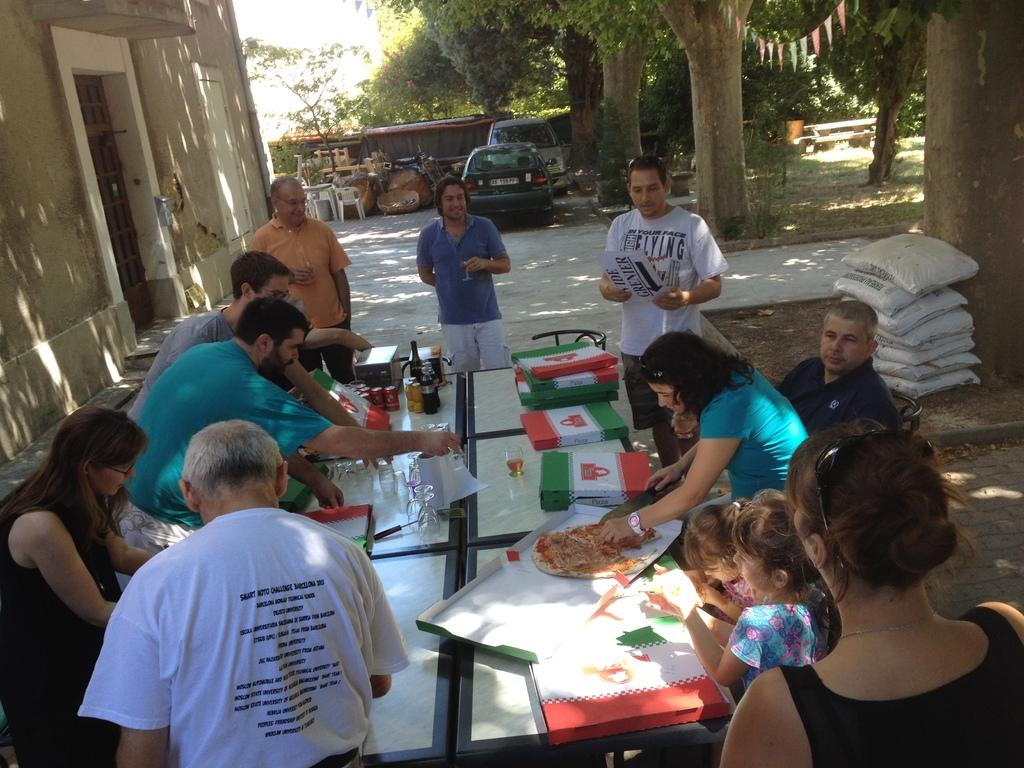What is happening at the table in the image? There are people gathered around a table, and a woman is cutting a pizza. Who is present near the woman cutting the pizza? There are children beside the woman. What can be seen in the distance from the table? There are two cars at a distance. What type of natural elements are present in the surroundings? There are trees in the surroundings. What rhythm is the woman using to cut the pizza in the image? There is no indication of a specific rhythm in the image; the woman is simply cutting the pizza. 